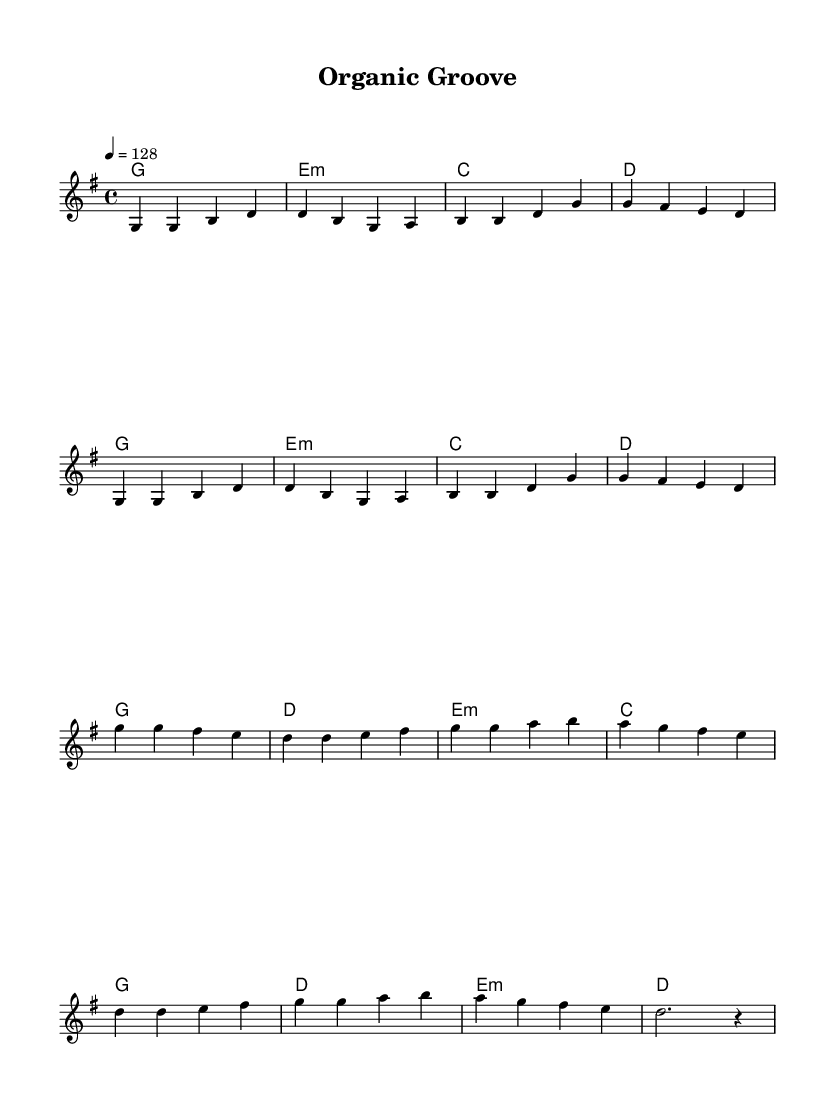what is the key signature of this music? The key signature is G major, which has one sharp (F#). This can be determined by looking at the key signature indicated at the beginning of the music.
Answer: G major what is the time signature of this music? The time signature is 4/4, as indicated at the beginning of the sheet music. It denotes four beats per measure, with each quarter note receiving one beat.
Answer: 4/4 what is the tempo marking of this music? The tempo is marked at quarter note = 128, which indicates how fast the music should be played. This can be found next to the tempo indication at the top of the score.
Answer: 128 how many measures are in the verses? The verses contain four measures, shown by the note grouping in the melody section labeled as "Verse". Count the distinct bar lines to confirm.
Answer: 4 what is the first note of the chorus? The first note of the chorus is G. It can be identified by looking at the melody section starting from the line that indicates the beginning of the chorus.
Answer: G why is the chord progression significant in K-Pop? The chord progression is significant in K-Pop as it often features emotional transitions that enhance the thematic elements of the song. In this piece, the progression complements the melody's energetic feel, common in K-Pop tracks, by uplifting the mood and creating a dynamic sound.
Answer: Emotional transitions 